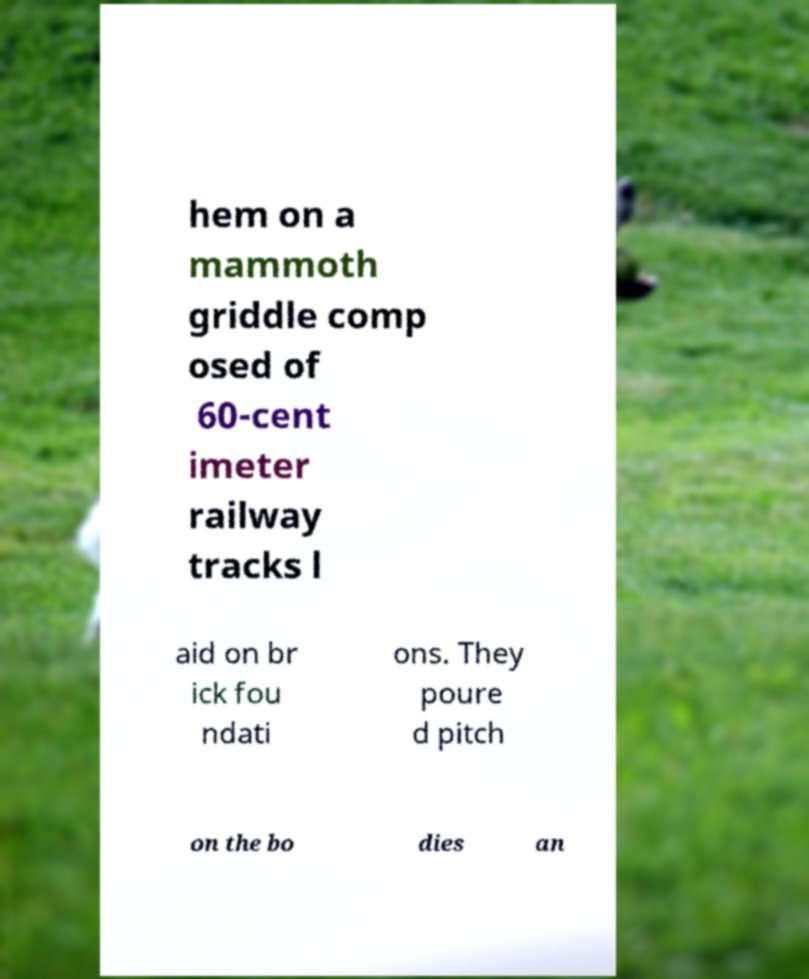Please identify and transcribe the text found in this image. hem on a mammoth griddle comp osed of 60-cent imeter railway tracks l aid on br ick fou ndati ons. They poure d pitch on the bo dies an 